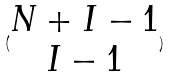<formula> <loc_0><loc_0><loc_500><loc_500>( \begin{matrix} N + I - 1 \\ I - 1 \end{matrix} )</formula> 